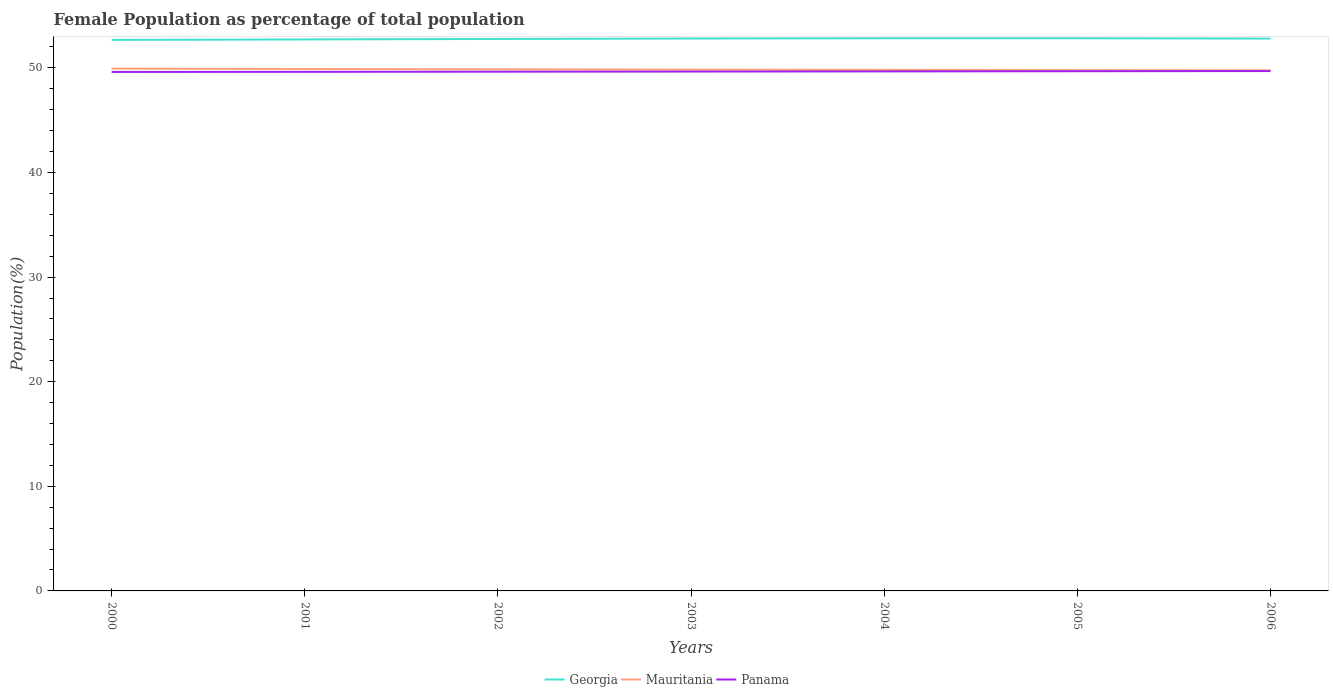How many different coloured lines are there?
Your answer should be very brief. 3. Across all years, what is the maximum female population in in Georgia?
Offer a very short reply. 52.67. What is the total female population in in Georgia in the graph?
Offer a terse response. -0.07. What is the difference between the highest and the second highest female population in in Mauritania?
Your response must be concise. 0.16. What is the difference between the highest and the lowest female population in in Georgia?
Provide a succinct answer. 4. How many years are there in the graph?
Provide a short and direct response. 7. How many legend labels are there?
Offer a very short reply. 3. How are the legend labels stacked?
Your answer should be very brief. Horizontal. What is the title of the graph?
Ensure brevity in your answer.  Female Population as percentage of total population. Does "St. Kitts and Nevis" appear as one of the legend labels in the graph?
Make the answer very short. No. What is the label or title of the X-axis?
Your response must be concise. Years. What is the label or title of the Y-axis?
Offer a terse response. Population(%). What is the Population(%) in Georgia in 2000?
Provide a succinct answer. 52.67. What is the Population(%) in Mauritania in 2000?
Keep it short and to the point. 49.93. What is the Population(%) of Panama in 2000?
Your response must be concise. 49.61. What is the Population(%) in Georgia in 2001?
Offer a terse response. 52.72. What is the Population(%) in Mauritania in 2001?
Offer a very short reply. 49.9. What is the Population(%) in Panama in 2001?
Your response must be concise. 49.62. What is the Population(%) in Georgia in 2002?
Make the answer very short. 52.76. What is the Population(%) in Mauritania in 2002?
Make the answer very short. 49.86. What is the Population(%) of Panama in 2002?
Your answer should be compact. 49.63. What is the Population(%) of Georgia in 2003?
Your answer should be compact. 52.81. What is the Population(%) of Mauritania in 2003?
Provide a short and direct response. 49.83. What is the Population(%) of Panama in 2003?
Your answer should be compact. 49.65. What is the Population(%) in Georgia in 2004?
Give a very brief answer. 52.83. What is the Population(%) in Mauritania in 2004?
Your answer should be very brief. 49.8. What is the Population(%) in Panama in 2004?
Give a very brief answer. 49.66. What is the Population(%) in Georgia in 2005?
Your answer should be very brief. 52.83. What is the Population(%) of Mauritania in 2005?
Offer a terse response. 49.78. What is the Population(%) in Panama in 2005?
Provide a short and direct response. 49.68. What is the Population(%) in Georgia in 2006?
Make the answer very short. 52.8. What is the Population(%) in Mauritania in 2006?
Provide a succinct answer. 49.77. What is the Population(%) of Panama in 2006?
Your response must be concise. 49.7. Across all years, what is the maximum Population(%) of Georgia?
Provide a succinct answer. 52.83. Across all years, what is the maximum Population(%) in Mauritania?
Make the answer very short. 49.93. Across all years, what is the maximum Population(%) of Panama?
Provide a succinct answer. 49.7. Across all years, what is the minimum Population(%) in Georgia?
Your answer should be compact. 52.67. Across all years, what is the minimum Population(%) of Mauritania?
Keep it short and to the point. 49.77. Across all years, what is the minimum Population(%) of Panama?
Offer a terse response. 49.61. What is the total Population(%) of Georgia in the graph?
Keep it short and to the point. 369.42. What is the total Population(%) in Mauritania in the graph?
Offer a terse response. 348.87. What is the total Population(%) of Panama in the graph?
Ensure brevity in your answer.  347.55. What is the difference between the Population(%) in Georgia in 2000 and that in 2001?
Offer a terse response. -0.04. What is the difference between the Population(%) of Mauritania in 2000 and that in 2001?
Offer a very short reply. 0.03. What is the difference between the Population(%) in Panama in 2000 and that in 2001?
Provide a short and direct response. -0.01. What is the difference between the Population(%) in Georgia in 2000 and that in 2002?
Offer a terse response. -0.09. What is the difference between the Population(%) of Mauritania in 2000 and that in 2002?
Offer a terse response. 0.07. What is the difference between the Population(%) of Panama in 2000 and that in 2002?
Give a very brief answer. -0.03. What is the difference between the Population(%) in Georgia in 2000 and that in 2003?
Provide a short and direct response. -0.13. What is the difference between the Population(%) of Mauritania in 2000 and that in 2003?
Keep it short and to the point. 0.1. What is the difference between the Population(%) in Panama in 2000 and that in 2003?
Ensure brevity in your answer.  -0.04. What is the difference between the Population(%) in Georgia in 2000 and that in 2004?
Give a very brief answer. -0.16. What is the difference between the Population(%) in Mauritania in 2000 and that in 2004?
Your answer should be compact. 0.12. What is the difference between the Population(%) of Panama in 2000 and that in 2004?
Give a very brief answer. -0.05. What is the difference between the Population(%) of Georgia in 2000 and that in 2005?
Provide a succinct answer. -0.16. What is the difference between the Population(%) of Mauritania in 2000 and that in 2005?
Make the answer very short. 0.15. What is the difference between the Population(%) of Panama in 2000 and that in 2005?
Make the answer very short. -0.07. What is the difference between the Population(%) in Georgia in 2000 and that in 2006?
Provide a succinct answer. -0.13. What is the difference between the Population(%) in Mauritania in 2000 and that in 2006?
Your answer should be compact. 0.16. What is the difference between the Population(%) of Panama in 2000 and that in 2006?
Make the answer very short. -0.09. What is the difference between the Population(%) in Georgia in 2001 and that in 2002?
Keep it short and to the point. -0.05. What is the difference between the Population(%) in Mauritania in 2001 and that in 2002?
Ensure brevity in your answer.  0.03. What is the difference between the Population(%) in Panama in 2001 and that in 2002?
Your response must be concise. -0.01. What is the difference between the Population(%) of Georgia in 2001 and that in 2003?
Give a very brief answer. -0.09. What is the difference between the Population(%) of Mauritania in 2001 and that in 2003?
Your response must be concise. 0.06. What is the difference between the Population(%) in Panama in 2001 and that in 2003?
Keep it short and to the point. -0.03. What is the difference between the Population(%) in Georgia in 2001 and that in 2004?
Make the answer very short. -0.11. What is the difference between the Population(%) of Mauritania in 2001 and that in 2004?
Give a very brief answer. 0.09. What is the difference between the Population(%) in Panama in 2001 and that in 2004?
Offer a very short reply. -0.04. What is the difference between the Population(%) of Georgia in 2001 and that in 2005?
Provide a short and direct response. -0.11. What is the difference between the Population(%) in Mauritania in 2001 and that in 2005?
Provide a short and direct response. 0.11. What is the difference between the Population(%) in Panama in 2001 and that in 2005?
Your response must be concise. -0.06. What is the difference between the Population(%) in Georgia in 2001 and that in 2006?
Your answer should be compact. -0.08. What is the difference between the Population(%) in Mauritania in 2001 and that in 2006?
Make the answer very short. 0.13. What is the difference between the Population(%) of Panama in 2001 and that in 2006?
Offer a terse response. -0.07. What is the difference between the Population(%) of Georgia in 2002 and that in 2003?
Offer a terse response. -0.04. What is the difference between the Population(%) in Mauritania in 2002 and that in 2003?
Your response must be concise. 0.03. What is the difference between the Population(%) in Panama in 2002 and that in 2003?
Your response must be concise. -0.01. What is the difference between the Population(%) of Georgia in 2002 and that in 2004?
Ensure brevity in your answer.  -0.07. What is the difference between the Population(%) in Mauritania in 2002 and that in 2004?
Offer a terse response. 0.06. What is the difference between the Population(%) of Panama in 2002 and that in 2004?
Your response must be concise. -0.03. What is the difference between the Population(%) of Georgia in 2002 and that in 2005?
Keep it short and to the point. -0.07. What is the difference between the Population(%) of Mauritania in 2002 and that in 2005?
Provide a short and direct response. 0.08. What is the difference between the Population(%) in Panama in 2002 and that in 2005?
Keep it short and to the point. -0.04. What is the difference between the Population(%) of Georgia in 2002 and that in 2006?
Provide a short and direct response. -0.04. What is the difference between the Population(%) in Mauritania in 2002 and that in 2006?
Keep it short and to the point. 0.09. What is the difference between the Population(%) of Panama in 2002 and that in 2006?
Your response must be concise. -0.06. What is the difference between the Population(%) in Georgia in 2003 and that in 2004?
Your answer should be compact. -0.02. What is the difference between the Population(%) in Mauritania in 2003 and that in 2004?
Give a very brief answer. 0.03. What is the difference between the Population(%) in Panama in 2003 and that in 2004?
Keep it short and to the point. -0.01. What is the difference between the Population(%) in Georgia in 2003 and that in 2005?
Provide a succinct answer. -0.02. What is the difference between the Population(%) of Mauritania in 2003 and that in 2005?
Give a very brief answer. 0.05. What is the difference between the Population(%) of Panama in 2003 and that in 2005?
Give a very brief answer. -0.03. What is the difference between the Population(%) in Georgia in 2003 and that in 2006?
Your response must be concise. 0.01. What is the difference between the Population(%) of Mauritania in 2003 and that in 2006?
Your answer should be very brief. 0.06. What is the difference between the Population(%) in Panama in 2003 and that in 2006?
Ensure brevity in your answer.  -0.05. What is the difference between the Population(%) of Mauritania in 2004 and that in 2005?
Give a very brief answer. 0.02. What is the difference between the Population(%) of Panama in 2004 and that in 2005?
Provide a succinct answer. -0.02. What is the difference between the Population(%) in Georgia in 2004 and that in 2006?
Your answer should be very brief. 0.03. What is the difference between the Population(%) of Mauritania in 2004 and that in 2006?
Your answer should be very brief. 0.04. What is the difference between the Population(%) of Panama in 2004 and that in 2006?
Ensure brevity in your answer.  -0.03. What is the difference between the Population(%) in Georgia in 2005 and that in 2006?
Offer a very short reply. 0.03. What is the difference between the Population(%) of Mauritania in 2005 and that in 2006?
Make the answer very short. 0.02. What is the difference between the Population(%) of Panama in 2005 and that in 2006?
Provide a succinct answer. -0.02. What is the difference between the Population(%) in Georgia in 2000 and the Population(%) in Mauritania in 2001?
Make the answer very short. 2.78. What is the difference between the Population(%) in Georgia in 2000 and the Population(%) in Panama in 2001?
Your answer should be compact. 3.05. What is the difference between the Population(%) in Mauritania in 2000 and the Population(%) in Panama in 2001?
Provide a short and direct response. 0.31. What is the difference between the Population(%) in Georgia in 2000 and the Population(%) in Mauritania in 2002?
Your answer should be compact. 2.81. What is the difference between the Population(%) in Georgia in 2000 and the Population(%) in Panama in 2002?
Keep it short and to the point. 3.04. What is the difference between the Population(%) in Mauritania in 2000 and the Population(%) in Panama in 2002?
Ensure brevity in your answer.  0.29. What is the difference between the Population(%) in Georgia in 2000 and the Population(%) in Mauritania in 2003?
Offer a very short reply. 2.84. What is the difference between the Population(%) in Georgia in 2000 and the Population(%) in Panama in 2003?
Make the answer very short. 3.03. What is the difference between the Population(%) of Mauritania in 2000 and the Population(%) of Panama in 2003?
Give a very brief answer. 0.28. What is the difference between the Population(%) in Georgia in 2000 and the Population(%) in Mauritania in 2004?
Offer a very short reply. 2.87. What is the difference between the Population(%) of Georgia in 2000 and the Population(%) of Panama in 2004?
Offer a very short reply. 3.01. What is the difference between the Population(%) of Mauritania in 2000 and the Population(%) of Panama in 2004?
Offer a terse response. 0.27. What is the difference between the Population(%) in Georgia in 2000 and the Population(%) in Mauritania in 2005?
Provide a short and direct response. 2.89. What is the difference between the Population(%) of Georgia in 2000 and the Population(%) of Panama in 2005?
Offer a very short reply. 2.99. What is the difference between the Population(%) in Mauritania in 2000 and the Population(%) in Panama in 2005?
Provide a succinct answer. 0.25. What is the difference between the Population(%) in Georgia in 2000 and the Population(%) in Mauritania in 2006?
Your answer should be compact. 2.91. What is the difference between the Population(%) of Georgia in 2000 and the Population(%) of Panama in 2006?
Provide a short and direct response. 2.98. What is the difference between the Population(%) of Mauritania in 2000 and the Population(%) of Panama in 2006?
Your answer should be compact. 0.23. What is the difference between the Population(%) in Georgia in 2001 and the Population(%) in Mauritania in 2002?
Provide a short and direct response. 2.86. What is the difference between the Population(%) of Georgia in 2001 and the Population(%) of Panama in 2002?
Your response must be concise. 3.08. What is the difference between the Population(%) in Mauritania in 2001 and the Population(%) in Panama in 2002?
Ensure brevity in your answer.  0.26. What is the difference between the Population(%) of Georgia in 2001 and the Population(%) of Mauritania in 2003?
Keep it short and to the point. 2.89. What is the difference between the Population(%) of Georgia in 2001 and the Population(%) of Panama in 2003?
Ensure brevity in your answer.  3.07. What is the difference between the Population(%) of Mauritania in 2001 and the Population(%) of Panama in 2003?
Ensure brevity in your answer.  0.25. What is the difference between the Population(%) in Georgia in 2001 and the Population(%) in Mauritania in 2004?
Keep it short and to the point. 2.91. What is the difference between the Population(%) in Georgia in 2001 and the Population(%) in Panama in 2004?
Give a very brief answer. 3.05. What is the difference between the Population(%) of Mauritania in 2001 and the Population(%) of Panama in 2004?
Provide a succinct answer. 0.23. What is the difference between the Population(%) of Georgia in 2001 and the Population(%) of Mauritania in 2005?
Give a very brief answer. 2.93. What is the difference between the Population(%) of Georgia in 2001 and the Population(%) of Panama in 2005?
Offer a terse response. 3.04. What is the difference between the Population(%) in Mauritania in 2001 and the Population(%) in Panama in 2005?
Offer a terse response. 0.22. What is the difference between the Population(%) of Georgia in 2001 and the Population(%) of Mauritania in 2006?
Offer a very short reply. 2.95. What is the difference between the Population(%) of Georgia in 2001 and the Population(%) of Panama in 2006?
Provide a succinct answer. 3.02. What is the difference between the Population(%) of Mauritania in 2001 and the Population(%) of Panama in 2006?
Your response must be concise. 0.2. What is the difference between the Population(%) of Georgia in 2002 and the Population(%) of Mauritania in 2003?
Your answer should be compact. 2.93. What is the difference between the Population(%) of Georgia in 2002 and the Population(%) of Panama in 2003?
Provide a succinct answer. 3.12. What is the difference between the Population(%) of Mauritania in 2002 and the Population(%) of Panama in 2003?
Ensure brevity in your answer.  0.21. What is the difference between the Population(%) in Georgia in 2002 and the Population(%) in Mauritania in 2004?
Provide a succinct answer. 2.96. What is the difference between the Population(%) in Georgia in 2002 and the Population(%) in Panama in 2004?
Give a very brief answer. 3.1. What is the difference between the Population(%) of Mauritania in 2002 and the Population(%) of Panama in 2004?
Give a very brief answer. 0.2. What is the difference between the Population(%) in Georgia in 2002 and the Population(%) in Mauritania in 2005?
Make the answer very short. 2.98. What is the difference between the Population(%) in Georgia in 2002 and the Population(%) in Panama in 2005?
Offer a terse response. 3.09. What is the difference between the Population(%) in Mauritania in 2002 and the Population(%) in Panama in 2005?
Your answer should be very brief. 0.18. What is the difference between the Population(%) of Georgia in 2002 and the Population(%) of Mauritania in 2006?
Your answer should be compact. 3. What is the difference between the Population(%) in Georgia in 2002 and the Population(%) in Panama in 2006?
Your answer should be compact. 3.07. What is the difference between the Population(%) of Mauritania in 2002 and the Population(%) of Panama in 2006?
Make the answer very short. 0.17. What is the difference between the Population(%) of Georgia in 2003 and the Population(%) of Mauritania in 2004?
Your response must be concise. 3. What is the difference between the Population(%) of Georgia in 2003 and the Population(%) of Panama in 2004?
Offer a terse response. 3.14. What is the difference between the Population(%) in Mauritania in 2003 and the Population(%) in Panama in 2004?
Keep it short and to the point. 0.17. What is the difference between the Population(%) in Georgia in 2003 and the Population(%) in Mauritania in 2005?
Provide a succinct answer. 3.02. What is the difference between the Population(%) of Georgia in 2003 and the Population(%) of Panama in 2005?
Offer a terse response. 3.13. What is the difference between the Population(%) in Mauritania in 2003 and the Population(%) in Panama in 2005?
Keep it short and to the point. 0.15. What is the difference between the Population(%) in Georgia in 2003 and the Population(%) in Mauritania in 2006?
Keep it short and to the point. 3.04. What is the difference between the Population(%) in Georgia in 2003 and the Population(%) in Panama in 2006?
Make the answer very short. 3.11. What is the difference between the Population(%) in Mauritania in 2003 and the Population(%) in Panama in 2006?
Your response must be concise. 0.14. What is the difference between the Population(%) of Georgia in 2004 and the Population(%) of Mauritania in 2005?
Your answer should be very brief. 3.05. What is the difference between the Population(%) of Georgia in 2004 and the Population(%) of Panama in 2005?
Make the answer very short. 3.15. What is the difference between the Population(%) of Mauritania in 2004 and the Population(%) of Panama in 2005?
Offer a very short reply. 0.13. What is the difference between the Population(%) in Georgia in 2004 and the Population(%) in Mauritania in 2006?
Offer a terse response. 3.06. What is the difference between the Population(%) of Georgia in 2004 and the Population(%) of Panama in 2006?
Ensure brevity in your answer.  3.13. What is the difference between the Population(%) of Mauritania in 2004 and the Population(%) of Panama in 2006?
Give a very brief answer. 0.11. What is the difference between the Population(%) in Georgia in 2005 and the Population(%) in Mauritania in 2006?
Your answer should be compact. 3.06. What is the difference between the Population(%) in Georgia in 2005 and the Population(%) in Panama in 2006?
Make the answer very short. 3.13. What is the difference between the Population(%) in Mauritania in 2005 and the Population(%) in Panama in 2006?
Give a very brief answer. 0.09. What is the average Population(%) in Georgia per year?
Ensure brevity in your answer.  52.77. What is the average Population(%) of Mauritania per year?
Keep it short and to the point. 49.84. What is the average Population(%) in Panama per year?
Your answer should be very brief. 49.65. In the year 2000, what is the difference between the Population(%) in Georgia and Population(%) in Mauritania?
Give a very brief answer. 2.75. In the year 2000, what is the difference between the Population(%) of Georgia and Population(%) of Panama?
Provide a succinct answer. 3.06. In the year 2000, what is the difference between the Population(%) in Mauritania and Population(%) in Panama?
Ensure brevity in your answer.  0.32. In the year 2001, what is the difference between the Population(%) of Georgia and Population(%) of Mauritania?
Your answer should be compact. 2.82. In the year 2001, what is the difference between the Population(%) in Georgia and Population(%) in Panama?
Keep it short and to the point. 3.1. In the year 2001, what is the difference between the Population(%) of Mauritania and Population(%) of Panama?
Make the answer very short. 0.27. In the year 2002, what is the difference between the Population(%) of Georgia and Population(%) of Mauritania?
Offer a very short reply. 2.9. In the year 2002, what is the difference between the Population(%) in Georgia and Population(%) in Panama?
Provide a succinct answer. 3.13. In the year 2002, what is the difference between the Population(%) in Mauritania and Population(%) in Panama?
Offer a terse response. 0.23. In the year 2003, what is the difference between the Population(%) of Georgia and Population(%) of Mauritania?
Keep it short and to the point. 2.97. In the year 2003, what is the difference between the Population(%) of Georgia and Population(%) of Panama?
Ensure brevity in your answer.  3.16. In the year 2003, what is the difference between the Population(%) of Mauritania and Population(%) of Panama?
Offer a very short reply. 0.18. In the year 2004, what is the difference between the Population(%) of Georgia and Population(%) of Mauritania?
Keep it short and to the point. 3.03. In the year 2004, what is the difference between the Population(%) in Georgia and Population(%) in Panama?
Your answer should be compact. 3.17. In the year 2004, what is the difference between the Population(%) in Mauritania and Population(%) in Panama?
Provide a short and direct response. 0.14. In the year 2005, what is the difference between the Population(%) of Georgia and Population(%) of Mauritania?
Offer a terse response. 3.05. In the year 2005, what is the difference between the Population(%) in Georgia and Population(%) in Panama?
Your answer should be very brief. 3.15. In the year 2005, what is the difference between the Population(%) in Mauritania and Population(%) in Panama?
Ensure brevity in your answer.  0.1. In the year 2006, what is the difference between the Population(%) of Georgia and Population(%) of Mauritania?
Keep it short and to the point. 3.03. In the year 2006, what is the difference between the Population(%) of Georgia and Population(%) of Panama?
Ensure brevity in your answer.  3.1. In the year 2006, what is the difference between the Population(%) of Mauritania and Population(%) of Panama?
Keep it short and to the point. 0.07. What is the ratio of the Population(%) in Georgia in 2000 to that in 2002?
Provide a short and direct response. 1. What is the ratio of the Population(%) in Mauritania in 2000 to that in 2002?
Your response must be concise. 1. What is the ratio of the Population(%) of Panama in 2000 to that in 2002?
Your answer should be very brief. 1. What is the ratio of the Population(%) of Panama in 2000 to that in 2003?
Your answer should be very brief. 1. What is the ratio of the Population(%) in Georgia in 2000 to that in 2006?
Your answer should be very brief. 1. What is the ratio of the Population(%) of Mauritania in 2000 to that in 2006?
Ensure brevity in your answer.  1. What is the ratio of the Population(%) in Panama in 2000 to that in 2006?
Your answer should be very brief. 1. What is the ratio of the Population(%) in Georgia in 2001 to that in 2002?
Offer a terse response. 1. What is the ratio of the Population(%) of Panama in 2001 to that in 2002?
Your response must be concise. 1. What is the ratio of the Population(%) in Georgia in 2001 to that in 2003?
Provide a succinct answer. 1. What is the ratio of the Population(%) of Panama in 2001 to that in 2003?
Keep it short and to the point. 1. What is the ratio of the Population(%) in Mauritania in 2001 to that in 2004?
Provide a short and direct response. 1. What is the ratio of the Population(%) of Georgia in 2001 to that in 2005?
Make the answer very short. 1. What is the ratio of the Population(%) in Panama in 2001 to that in 2006?
Give a very brief answer. 1. What is the ratio of the Population(%) of Panama in 2002 to that in 2003?
Offer a terse response. 1. What is the ratio of the Population(%) in Georgia in 2002 to that in 2004?
Ensure brevity in your answer.  1. What is the ratio of the Population(%) in Georgia in 2002 to that in 2005?
Your answer should be compact. 1. What is the ratio of the Population(%) in Mauritania in 2002 to that in 2005?
Provide a short and direct response. 1. What is the ratio of the Population(%) in Mauritania in 2002 to that in 2006?
Give a very brief answer. 1. What is the ratio of the Population(%) of Georgia in 2003 to that in 2004?
Your response must be concise. 1. What is the ratio of the Population(%) in Panama in 2003 to that in 2004?
Ensure brevity in your answer.  1. What is the ratio of the Population(%) in Georgia in 2003 to that in 2005?
Make the answer very short. 1. What is the ratio of the Population(%) in Panama in 2003 to that in 2005?
Make the answer very short. 1. What is the ratio of the Population(%) in Georgia in 2003 to that in 2006?
Your answer should be compact. 1. What is the ratio of the Population(%) in Mauritania in 2003 to that in 2006?
Make the answer very short. 1. What is the ratio of the Population(%) of Mauritania in 2004 to that in 2005?
Keep it short and to the point. 1. What is the ratio of the Population(%) of Georgia in 2004 to that in 2006?
Make the answer very short. 1. What is the ratio of the Population(%) in Panama in 2005 to that in 2006?
Provide a short and direct response. 1. What is the difference between the highest and the second highest Population(%) in Mauritania?
Make the answer very short. 0.03. What is the difference between the highest and the second highest Population(%) of Panama?
Your answer should be very brief. 0.02. What is the difference between the highest and the lowest Population(%) of Georgia?
Offer a terse response. 0.16. What is the difference between the highest and the lowest Population(%) in Mauritania?
Provide a succinct answer. 0.16. What is the difference between the highest and the lowest Population(%) in Panama?
Make the answer very short. 0.09. 